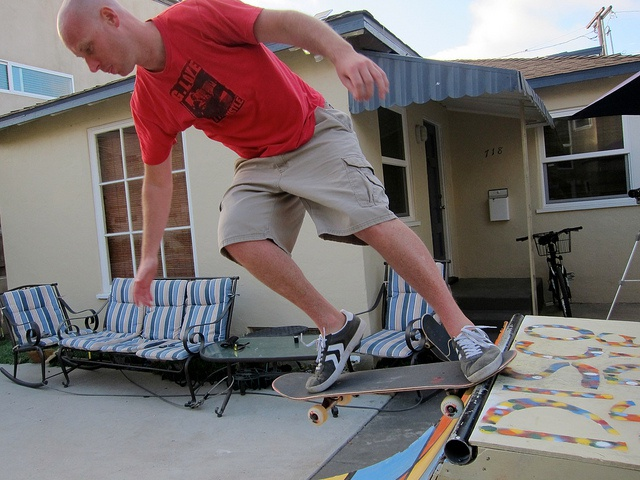Describe the objects in this image and their specific colors. I can see people in darkgray, brown, and gray tones, bench in darkgray, black, and gray tones, chair in darkgray, black, and gray tones, skateboard in darkgray, gray, and black tones, and chair in darkgray, black, and gray tones in this image. 